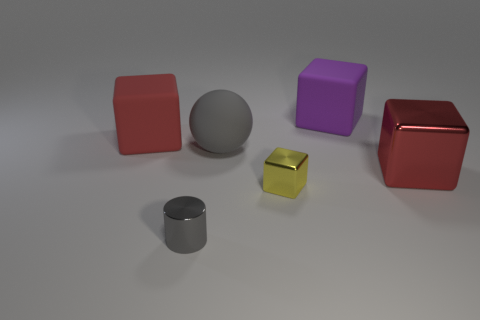How many objects are cubes that are right of the small metallic cylinder or brown matte cubes? There are a total of 2 cubes to the right of the small metallic cylinder, and while there are no brown matte cubes in the scene, there is one yellow matte cube. Therefore, the accurate count of the objects as per the given conditions would be 2. 